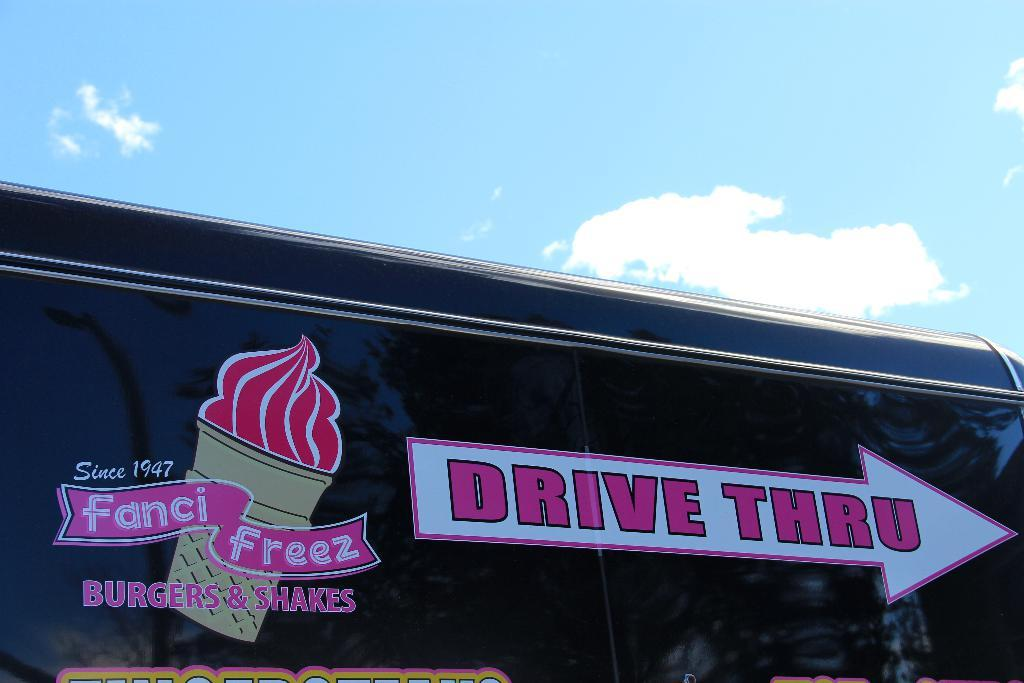What is present in the image that is used for displaying information or messages? There is a banner in the image that is used for displaying information or messages. What can be found on the banner? Something is written on the banner. What colors are visible in the sky in the image? The sky is blue and white in color. Are there any plantations visible in the image? There is no mention of a plantation in the provided facts, and therefore it cannot be determined if one is present in the image. 